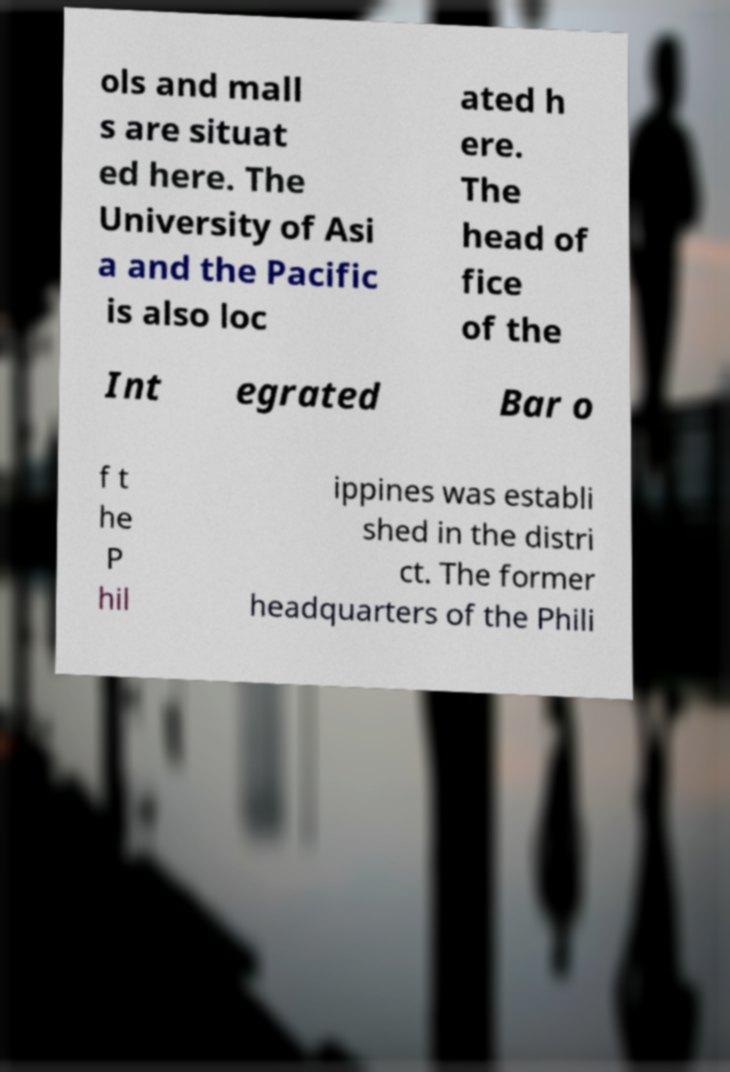I need the written content from this picture converted into text. Can you do that? ols and mall s are situat ed here. The University of Asi a and the Pacific is also loc ated h ere. The head of fice of the Int egrated Bar o f t he P hil ippines was establi shed in the distri ct. The former headquarters of the Phili 